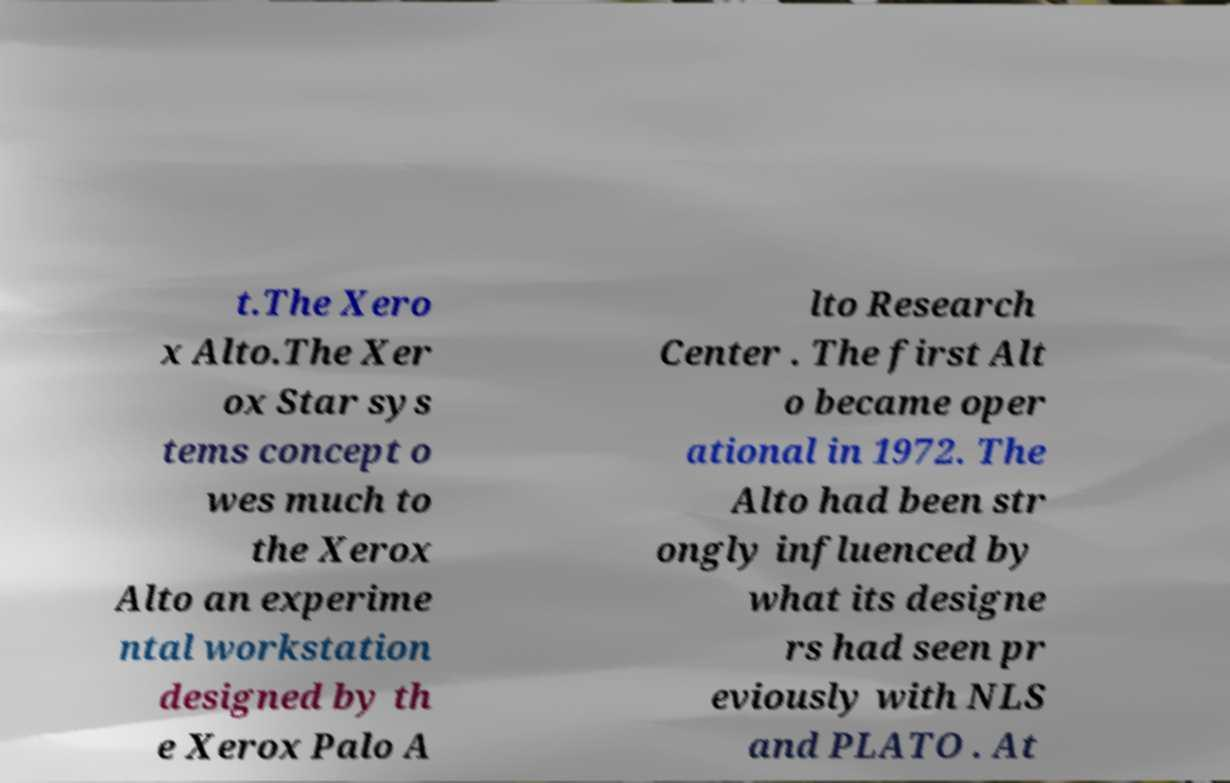Please identify and transcribe the text found in this image. t.The Xero x Alto.The Xer ox Star sys tems concept o wes much to the Xerox Alto an experime ntal workstation designed by th e Xerox Palo A lto Research Center . The first Alt o became oper ational in 1972. The Alto had been str ongly influenced by what its designe rs had seen pr eviously with NLS and PLATO . At 